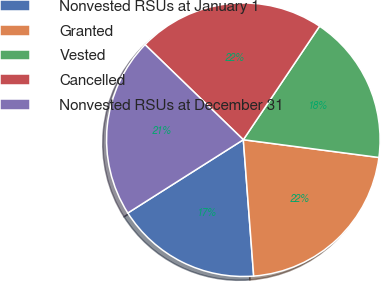<chart> <loc_0><loc_0><loc_500><loc_500><pie_chart><fcel>Nonvested RSUs at January 1<fcel>Granted<fcel>Vested<fcel>Cancelled<fcel>Nonvested RSUs at December 31<nl><fcel>17.21%<fcel>21.72%<fcel>17.66%<fcel>22.18%<fcel>21.23%<nl></chart> 